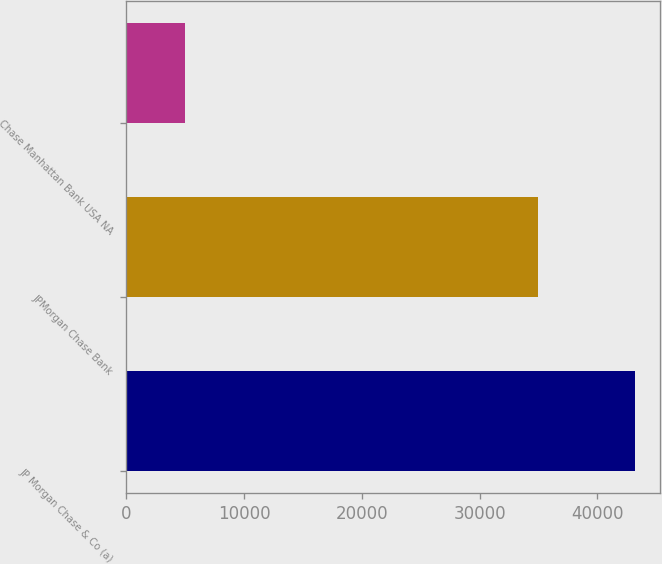<chart> <loc_0><loc_0><loc_500><loc_500><bar_chart><fcel>JP Morgan Chase & Co (a)<fcel>JPMorgan Chase Bank<fcel>Chase Manhattan Bank USA NA<nl><fcel>43167<fcel>34972<fcel>4950<nl></chart> 